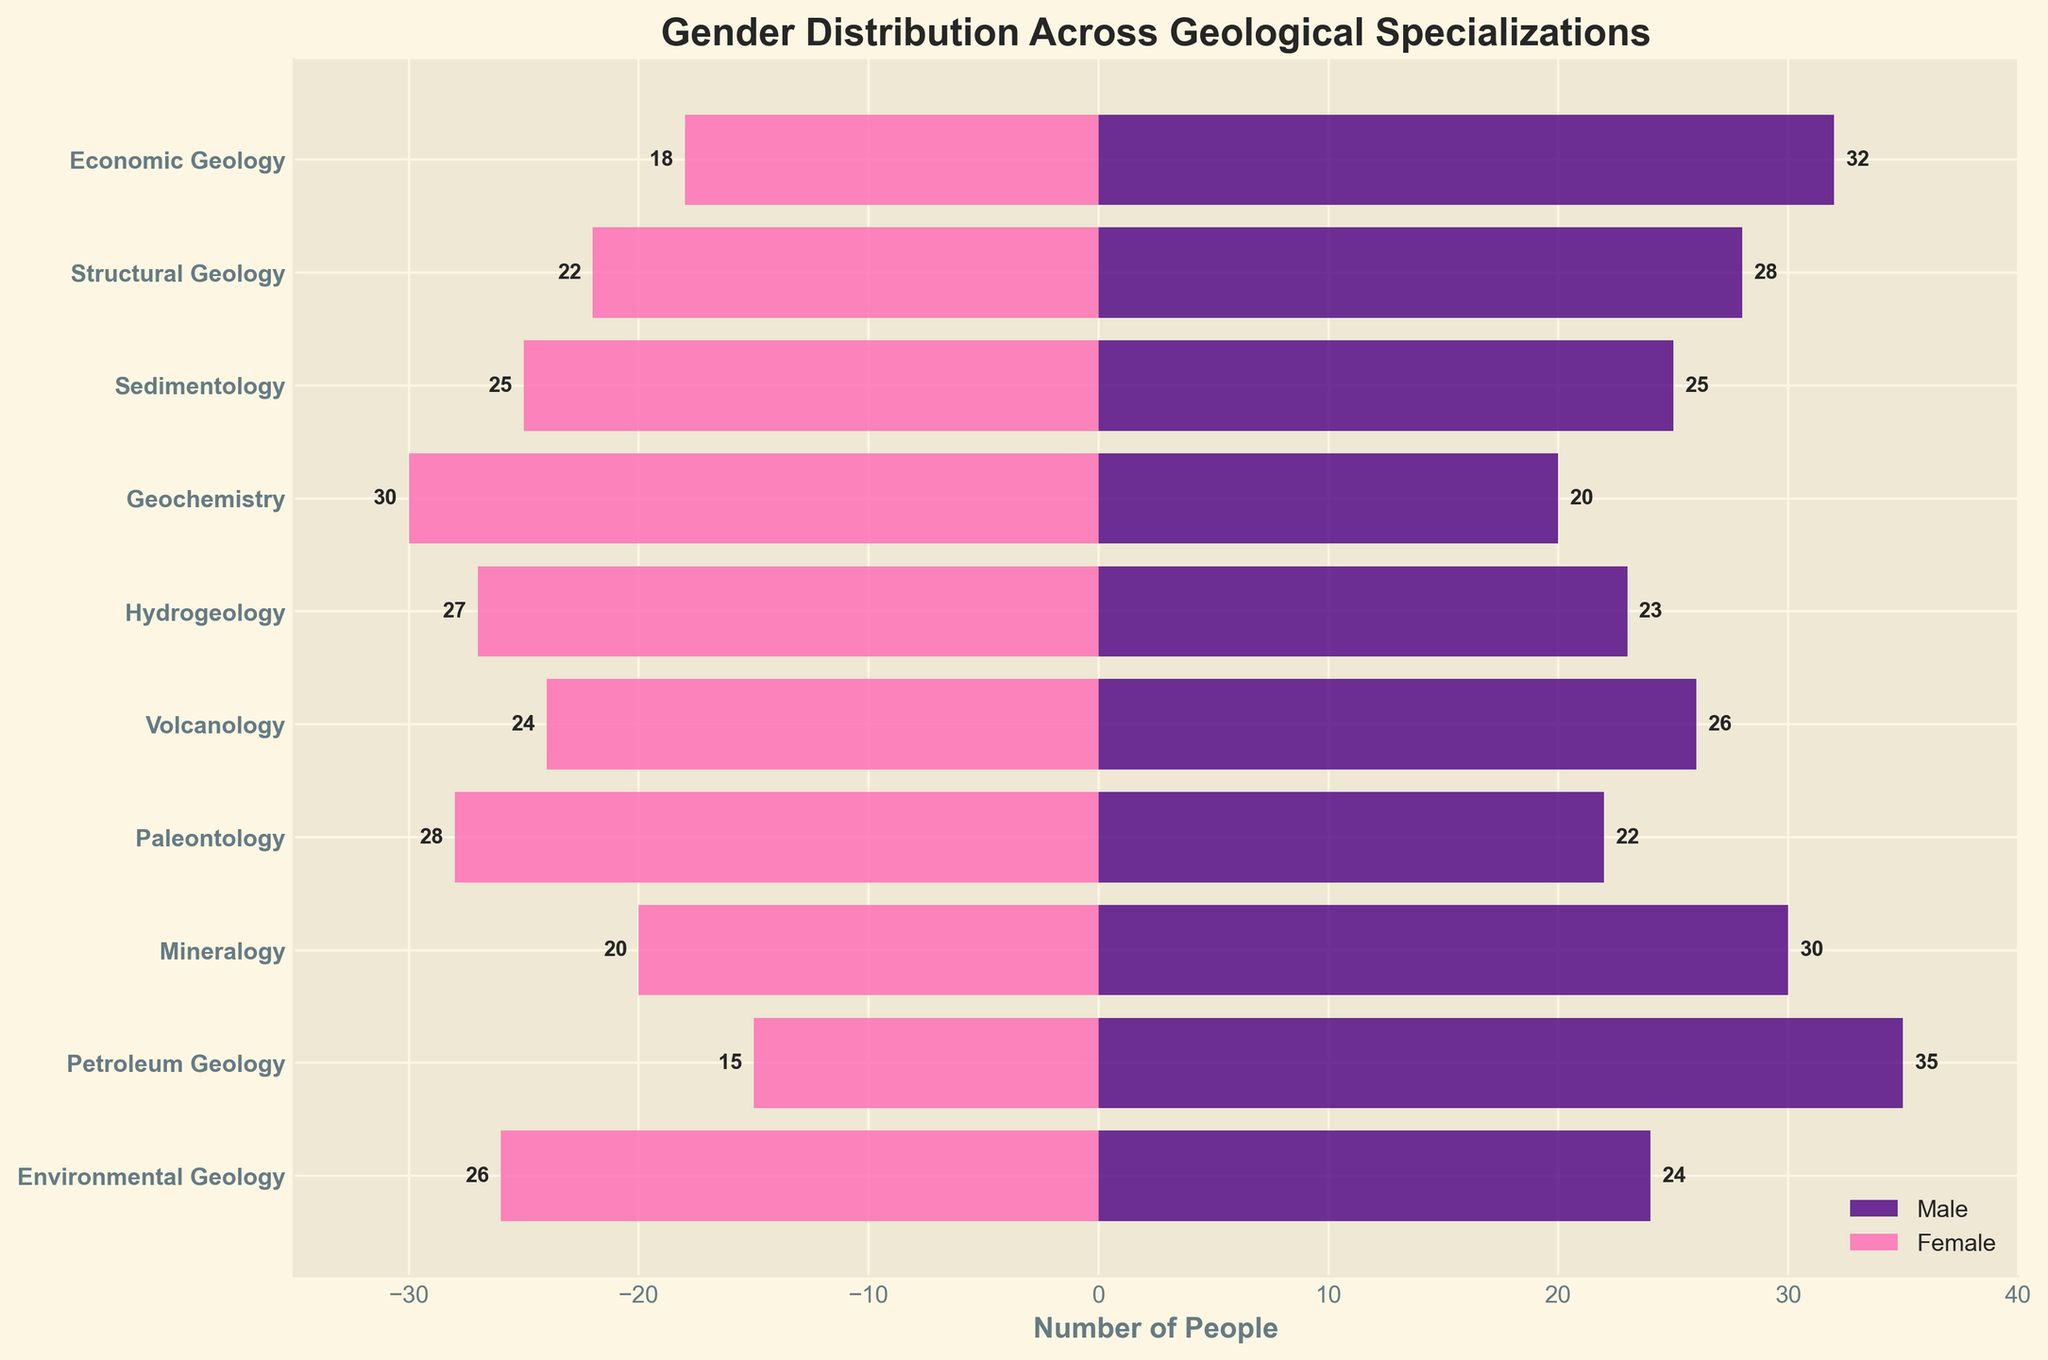What is the title of the plot? The title is located at the top of the plot, indicating the main subject of the figure.
Answer: Gender Distribution Across Geological Specializations Which specialization has the highest number of males? The longest bar pointing to the right on the male side indicates the highest number. For males, it is Petroleum Geology.
Answer: Petroleum Geology Which specialization has an equal number of males and females? The bars for males and females should be of the same length but on opposite sides. Sedimentology has both bars ending at the same point.
Answer: Sedimentology How many specializations have more females than males? Count the specializations where the female bar is longer (extending further to the left) than the male bar. These are Geochemistry, Hydrogeology, Paleontology, and Environmental Geology.
Answer: 4 What is the total number of females in all specializations? Add the values for females across all specializations: 18 + 22 + 25 + 30 + 27 + 24 + 28 + 20 + 15 + 26 = 235.
Answer: 235 What is the difference in the number of males and females in Economic Geology? Subtract the number of females from males in Economic Geology: 32 - 18 = 14.
Answer: 14 Which specialization has the smallest difference in the number of males and females? Look for the specialization where the bars for males and females are closest in length. For Hydrogeology, the difference is smallest (abs(23-27) = 4).
Answer: Hydrogeology What is the total number of people in Environmental Geology? Sum the number of males and females in Environmental Geology: 24 + 26 = 50.
Answer: 50 How many males are there in the specialization with the highest number of people? First, find the specialization with the highest sum of males and females, which is Economic Geology (32 + 18 = 50). The number of males is 32.
Answer: 32 Which specialization has more females than males and the largest overall number? From the specializations where females are more, calculate the total number (females + males). Geochemistry has 50 (20 + 30), which is the highest among Geochemistry, Hydrogeology, Paleontology, and Environmental Geology.
Answer: Geochemistry 